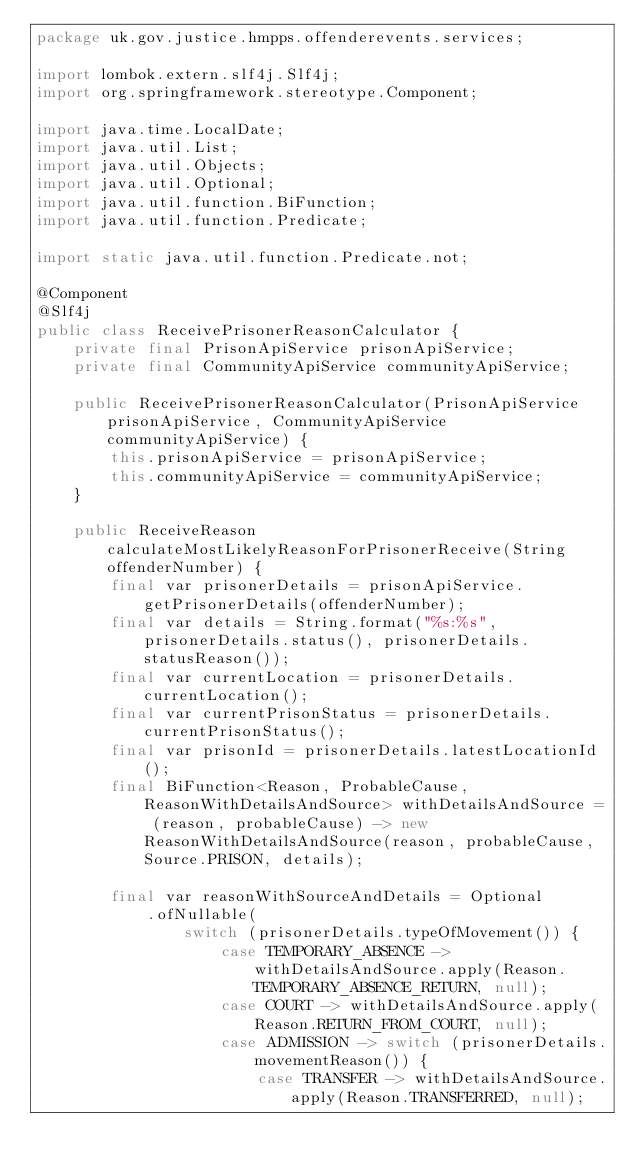<code> <loc_0><loc_0><loc_500><loc_500><_Java_>package uk.gov.justice.hmpps.offenderevents.services;

import lombok.extern.slf4j.Slf4j;
import org.springframework.stereotype.Component;

import java.time.LocalDate;
import java.util.List;
import java.util.Objects;
import java.util.Optional;
import java.util.function.BiFunction;
import java.util.function.Predicate;

import static java.util.function.Predicate.not;

@Component
@Slf4j
public class ReceivePrisonerReasonCalculator {
    private final PrisonApiService prisonApiService;
    private final CommunityApiService communityApiService;

    public ReceivePrisonerReasonCalculator(PrisonApiService prisonApiService, CommunityApiService communityApiService) {
        this.prisonApiService = prisonApiService;
        this.communityApiService = communityApiService;
    }

    public ReceiveReason calculateMostLikelyReasonForPrisonerReceive(String offenderNumber) {
        final var prisonerDetails = prisonApiService.getPrisonerDetails(offenderNumber);
        final var details = String.format("%s:%s", prisonerDetails.status(), prisonerDetails.statusReason());
        final var currentLocation = prisonerDetails.currentLocation();
        final var currentPrisonStatus = prisonerDetails.currentPrisonStatus();
        final var prisonId = prisonerDetails.latestLocationId();
        final BiFunction<Reason, ProbableCause, ReasonWithDetailsAndSource> withDetailsAndSource = (reason, probableCause) -> new ReasonWithDetailsAndSource(reason, probableCause, Source.PRISON, details);

        final var reasonWithSourceAndDetails = Optional
            .ofNullable(
                switch (prisonerDetails.typeOfMovement()) {
                    case TEMPORARY_ABSENCE -> withDetailsAndSource.apply(Reason.TEMPORARY_ABSENCE_RETURN, null);
                    case COURT -> withDetailsAndSource.apply(Reason.RETURN_FROM_COURT, null);
                    case ADMISSION -> switch (prisonerDetails.movementReason()) {
                        case TRANSFER -> withDetailsAndSource.apply(Reason.TRANSFERRED, null);</code> 